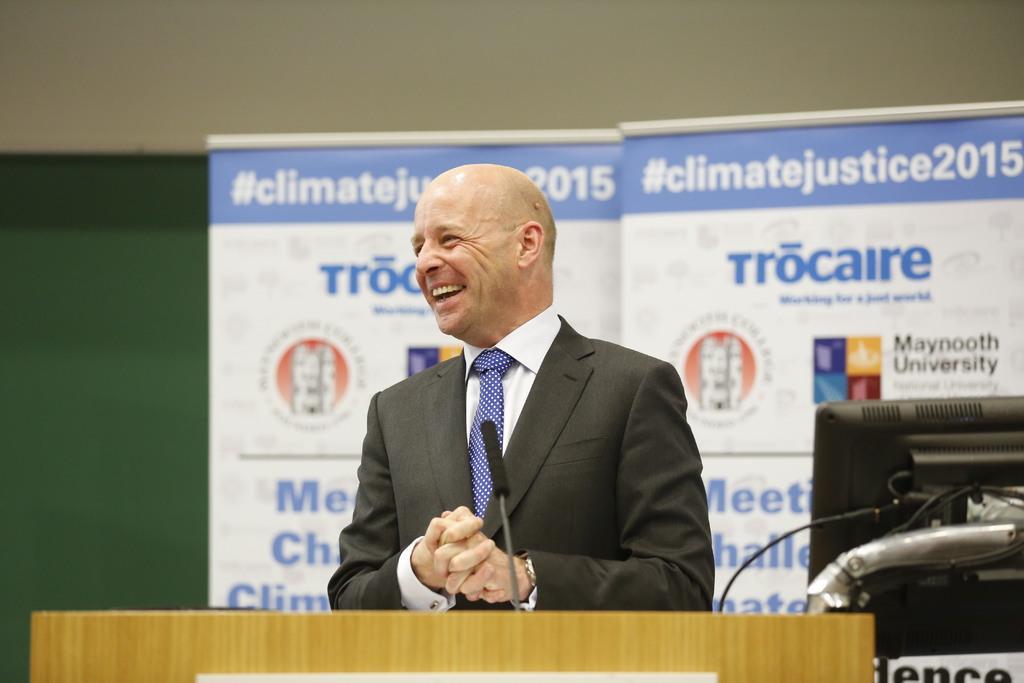Describe this image in one or two sentences. There is a man standing and smiling,in front of this man we can see microphone above the podium and we can see monitor. In the background we can see banners and wall. 